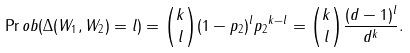Convert formula to latex. <formula><loc_0><loc_0><loc_500><loc_500>\Pr o b ( \Delta ( W _ { 1 } , W _ { 2 } ) = l ) = { k \choose l } ( 1 - p _ { 2 } ) ^ { l } { p _ { 2 } } ^ { k - l } = { k \choose l } \frac { ( d - 1 ) ^ { l } } { d ^ { k } } .</formula> 